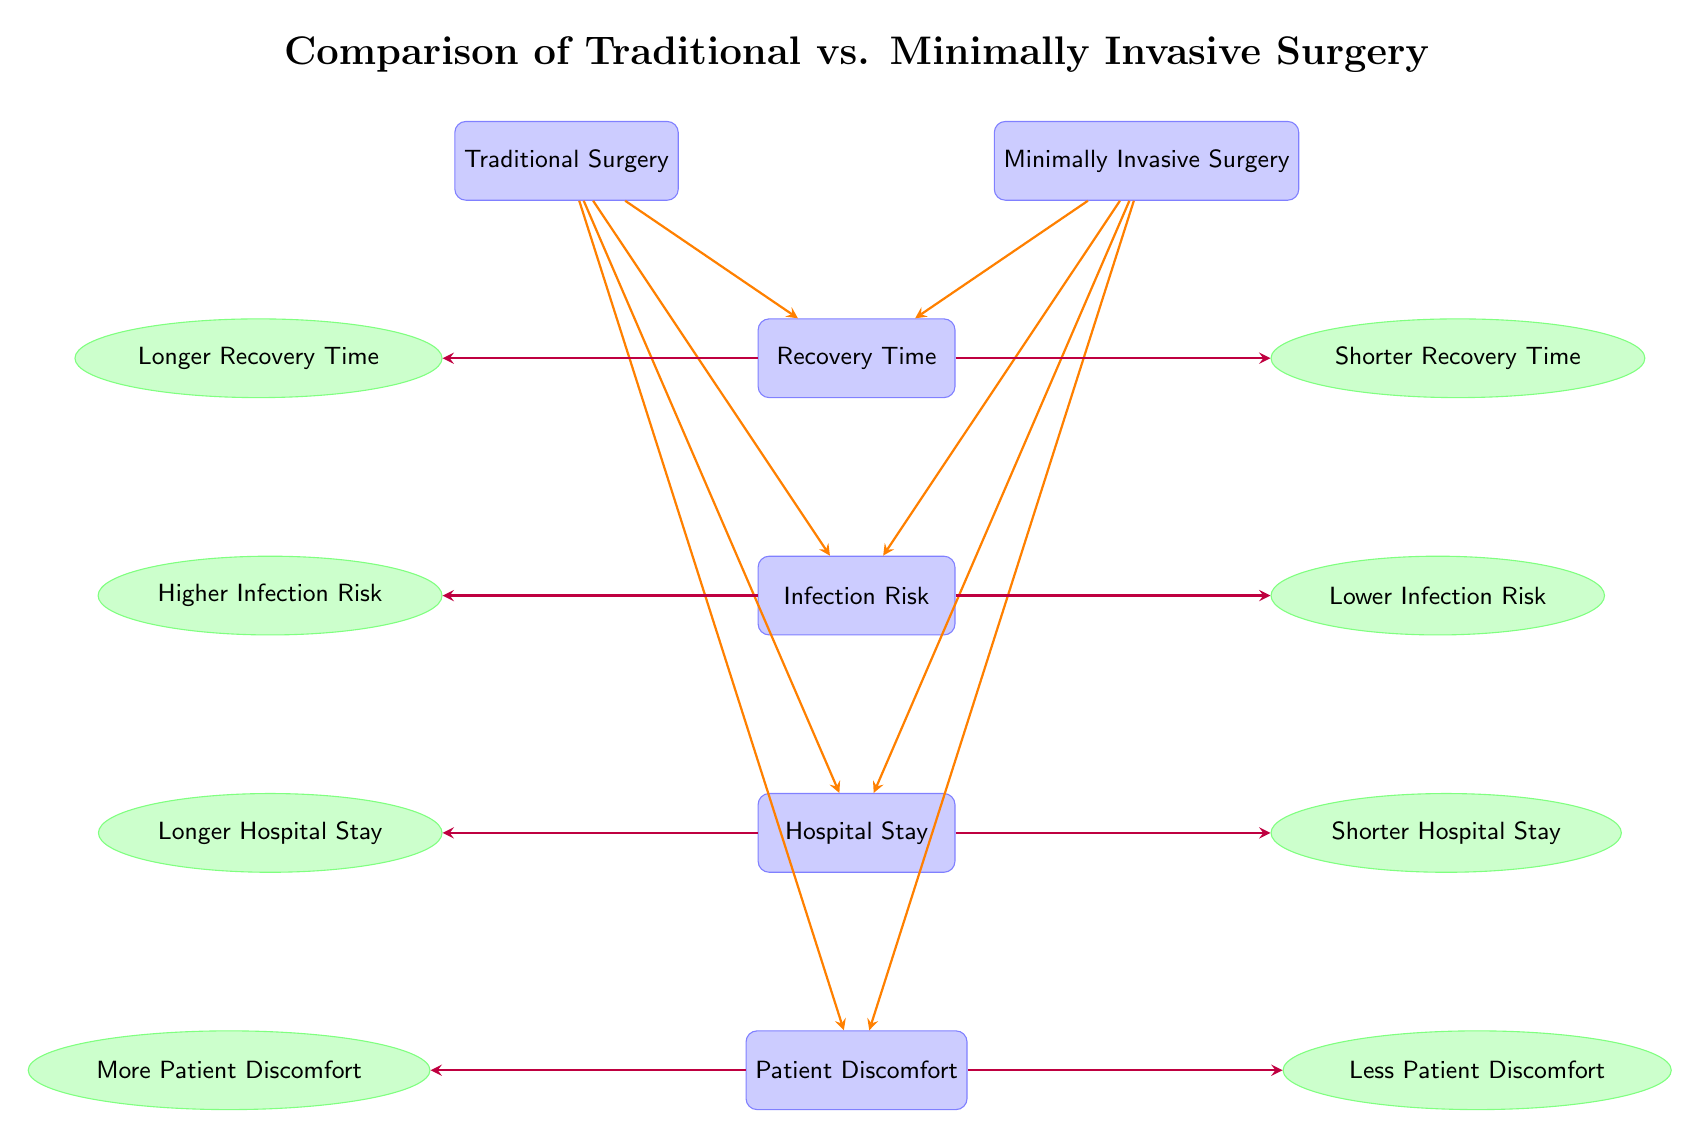What are the outcomes associated with Traditional Surgery? The outcomes associated with Traditional Surgery are displayed on the left side of the comparison diagram, which includes Longer Recovery Time, Higher Infection Risk, Longer Hospital Stay, and More Patient Discomfort. Each outcome is connected directly beneath the Traditional Surgery node.
Answer: Longer Recovery Time, Higher Infection Risk, Longer Hospital Stay, More Patient Discomfort What is the patient experience with Minimally Invasive Surgery in terms of discomfort? The diagram indicates that Minimally Invasive Surgery leads to Less Patient Discomfort, which is shown in the outcome node directly connected to the discomfort node on the right side of the diagram.
Answer: Less Patient Discomfort Which type of surgery has a shorter hospital stay? By analyzing the diagram, it is noted that Minimally Invasive Surgery is associated with a Shorter Hospital Stay, displayed in the outcome node right under the hospital stay node.
Answer: Shorter Hospital Stay What is the relationship between infection risk and surgical technique? The diagram shows a direct connection between the surgical technique and infection risk. Traditional Surgery is linked to Higher Infection Risk, whereas Minimally Invasive Surgery is linked to Lower Infection Risk, illustrating a contrast in outcomes based on the technique used.
Answer: Traditional Surgery: Higher Infection Risk; Minimally Invasive Surgery: Lower Infection Risk How many comparisons of outcomes are shown in the diagram? The diagram presents four main comparisons of outcomes: Recovery Time, Infection Risk, Hospital Stay, and Discomfort. Each of these is represented under the respective surgical techniques, making a total of four comparisons.
Answer: Four 